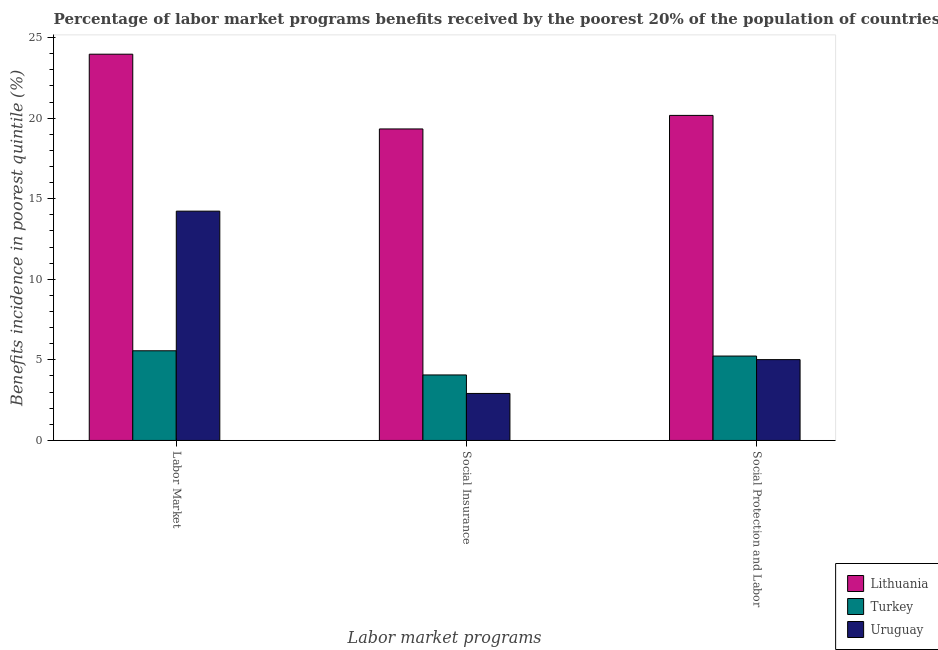How many groups of bars are there?
Offer a terse response. 3. Are the number of bars per tick equal to the number of legend labels?
Your answer should be compact. Yes. What is the label of the 3rd group of bars from the left?
Keep it short and to the point. Social Protection and Labor. What is the percentage of benefits received due to social insurance programs in Lithuania?
Provide a succinct answer. 19.33. Across all countries, what is the maximum percentage of benefits received due to social protection programs?
Keep it short and to the point. 20.17. Across all countries, what is the minimum percentage of benefits received due to social protection programs?
Offer a very short reply. 5.02. In which country was the percentage of benefits received due to social insurance programs maximum?
Your answer should be compact. Lithuania. What is the total percentage of benefits received due to social insurance programs in the graph?
Provide a succinct answer. 26.31. What is the difference between the percentage of benefits received due to labor market programs in Lithuania and that in Uruguay?
Your answer should be very brief. 9.74. What is the difference between the percentage of benefits received due to social insurance programs in Lithuania and the percentage of benefits received due to labor market programs in Uruguay?
Ensure brevity in your answer.  5.1. What is the average percentage of benefits received due to labor market programs per country?
Make the answer very short. 14.59. What is the difference between the percentage of benefits received due to labor market programs and percentage of benefits received due to social insurance programs in Lithuania?
Make the answer very short. 4.64. In how many countries, is the percentage of benefits received due to social insurance programs greater than 11 %?
Ensure brevity in your answer.  1. What is the ratio of the percentage of benefits received due to social protection programs in Lithuania to that in Turkey?
Offer a terse response. 3.85. What is the difference between the highest and the second highest percentage of benefits received due to social insurance programs?
Give a very brief answer. 15.26. What is the difference between the highest and the lowest percentage of benefits received due to social insurance programs?
Make the answer very short. 16.41. In how many countries, is the percentage of benefits received due to labor market programs greater than the average percentage of benefits received due to labor market programs taken over all countries?
Offer a terse response. 1. Is the sum of the percentage of benefits received due to labor market programs in Turkey and Lithuania greater than the maximum percentage of benefits received due to social protection programs across all countries?
Make the answer very short. Yes. What does the 1st bar from the left in Social Insurance represents?
Provide a succinct answer. Lithuania. What does the 2nd bar from the right in Social Protection and Labor represents?
Your answer should be compact. Turkey. Is it the case that in every country, the sum of the percentage of benefits received due to labor market programs and percentage of benefits received due to social insurance programs is greater than the percentage of benefits received due to social protection programs?
Make the answer very short. Yes. How many countries are there in the graph?
Offer a terse response. 3. Are the values on the major ticks of Y-axis written in scientific E-notation?
Offer a very short reply. No. Does the graph contain grids?
Ensure brevity in your answer.  No. Where does the legend appear in the graph?
Give a very brief answer. Bottom right. What is the title of the graph?
Your answer should be very brief. Percentage of labor market programs benefits received by the poorest 20% of the population of countries. Does "Latin America(all income levels)" appear as one of the legend labels in the graph?
Provide a short and direct response. No. What is the label or title of the X-axis?
Offer a terse response. Labor market programs. What is the label or title of the Y-axis?
Provide a succinct answer. Benefits incidence in poorest quintile (%). What is the Benefits incidence in poorest quintile (%) in Lithuania in Labor Market?
Provide a short and direct response. 23.97. What is the Benefits incidence in poorest quintile (%) of Turkey in Labor Market?
Keep it short and to the point. 5.56. What is the Benefits incidence in poorest quintile (%) in Uruguay in Labor Market?
Make the answer very short. 14.23. What is the Benefits incidence in poorest quintile (%) of Lithuania in Social Insurance?
Offer a very short reply. 19.33. What is the Benefits incidence in poorest quintile (%) of Turkey in Social Insurance?
Provide a succinct answer. 4.06. What is the Benefits incidence in poorest quintile (%) in Uruguay in Social Insurance?
Ensure brevity in your answer.  2.92. What is the Benefits incidence in poorest quintile (%) of Lithuania in Social Protection and Labor?
Offer a terse response. 20.17. What is the Benefits incidence in poorest quintile (%) of Turkey in Social Protection and Labor?
Your response must be concise. 5.24. What is the Benefits incidence in poorest quintile (%) of Uruguay in Social Protection and Labor?
Your answer should be very brief. 5.02. Across all Labor market programs, what is the maximum Benefits incidence in poorest quintile (%) of Lithuania?
Ensure brevity in your answer.  23.97. Across all Labor market programs, what is the maximum Benefits incidence in poorest quintile (%) in Turkey?
Your answer should be compact. 5.56. Across all Labor market programs, what is the maximum Benefits incidence in poorest quintile (%) of Uruguay?
Provide a succinct answer. 14.23. Across all Labor market programs, what is the minimum Benefits incidence in poorest quintile (%) in Lithuania?
Your response must be concise. 19.33. Across all Labor market programs, what is the minimum Benefits incidence in poorest quintile (%) in Turkey?
Your answer should be very brief. 4.06. Across all Labor market programs, what is the minimum Benefits incidence in poorest quintile (%) of Uruguay?
Your answer should be compact. 2.92. What is the total Benefits incidence in poorest quintile (%) in Lithuania in the graph?
Your answer should be very brief. 63.47. What is the total Benefits incidence in poorest quintile (%) in Turkey in the graph?
Offer a terse response. 14.87. What is the total Benefits incidence in poorest quintile (%) of Uruguay in the graph?
Provide a short and direct response. 22.16. What is the difference between the Benefits incidence in poorest quintile (%) in Lithuania in Labor Market and that in Social Insurance?
Give a very brief answer. 4.64. What is the difference between the Benefits incidence in poorest quintile (%) in Turkey in Labor Market and that in Social Insurance?
Offer a terse response. 1.5. What is the difference between the Benefits incidence in poorest quintile (%) of Uruguay in Labor Market and that in Social Insurance?
Your response must be concise. 11.31. What is the difference between the Benefits incidence in poorest quintile (%) in Lithuania in Labor Market and that in Social Protection and Labor?
Offer a terse response. 3.8. What is the difference between the Benefits incidence in poorest quintile (%) of Turkey in Labor Market and that in Social Protection and Labor?
Offer a very short reply. 0.33. What is the difference between the Benefits incidence in poorest quintile (%) of Uruguay in Labor Market and that in Social Protection and Labor?
Ensure brevity in your answer.  9.21. What is the difference between the Benefits incidence in poorest quintile (%) in Lithuania in Social Insurance and that in Social Protection and Labor?
Your response must be concise. -0.84. What is the difference between the Benefits incidence in poorest quintile (%) in Turkey in Social Insurance and that in Social Protection and Labor?
Provide a short and direct response. -1.17. What is the difference between the Benefits incidence in poorest quintile (%) in Uruguay in Social Insurance and that in Social Protection and Labor?
Keep it short and to the point. -2.1. What is the difference between the Benefits incidence in poorest quintile (%) in Lithuania in Labor Market and the Benefits incidence in poorest quintile (%) in Turkey in Social Insurance?
Your answer should be very brief. 19.9. What is the difference between the Benefits incidence in poorest quintile (%) of Lithuania in Labor Market and the Benefits incidence in poorest quintile (%) of Uruguay in Social Insurance?
Ensure brevity in your answer.  21.05. What is the difference between the Benefits incidence in poorest quintile (%) in Turkey in Labor Market and the Benefits incidence in poorest quintile (%) in Uruguay in Social Insurance?
Ensure brevity in your answer.  2.65. What is the difference between the Benefits incidence in poorest quintile (%) of Lithuania in Labor Market and the Benefits incidence in poorest quintile (%) of Turkey in Social Protection and Labor?
Ensure brevity in your answer.  18.73. What is the difference between the Benefits incidence in poorest quintile (%) in Lithuania in Labor Market and the Benefits incidence in poorest quintile (%) in Uruguay in Social Protection and Labor?
Your answer should be compact. 18.95. What is the difference between the Benefits incidence in poorest quintile (%) in Turkey in Labor Market and the Benefits incidence in poorest quintile (%) in Uruguay in Social Protection and Labor?
Provide a succinct answer. 0.55. What is the difference between the Benefits incidence in poorest quintile (%) in Lithuania in Social Insurance and the Benefits incidence in poorest quintile (%) in Turkey in Social Protection and Labor?
Provide a succinct answer. 14.09. What is the difference between the Benefits incidence in poorest quintile (%) of Lithuania in Social Insurance and the Benefits incidence in poorest quintile (%) of Uruguay in Social Protection and Labor?
Your answer should be compact. 14.31. What is the difference between the Benefits incidence in poorest quintile (%) in Turkey in Social Insurance and the Benefits incidence in poorest quintile (%) in Uruguay in Social Protection and Labor?
Give a very brief answer. -0.95. What is the average Benefits incidence in poorest quintile (%) of Lithuania per Labor market programs?
Give a very brief answer. 21.16. What is the average Benefits incidence in poorest quintile (%) in Turkey per Labor market programs?
Provide a short and direct response. 4.96. What is the average Benefits incidence in poorest quintile (%) in Uruguay per Labor market programs?
Ensure brevity in your answer.  7.39. What is the difference between the Benefits incidence in poorest quintile (%) of Lithuania and Benefits incidence in poorest quintile (%) of Turkey in Labor Market?
Your answer should be very brief. 18.4. What is the difference between the Benefits incidence in poorest quintile (%) of Lithuania and Benefits incidence in poorest quintile (%) of Uruguay in Labor Market?
Give a very brief answer. 9.74. What is the difference between the Benefits incidence in poorest quintile (%) in Turkey and Benefits incidence in poorest quintile (%) in Uruguay in Labor Market?
Provide a succinct answer. -8.66. What is the difference between the Benefits incidence in poorest quintile (%) in Lithuania and Benefits incidence in poorest quintile (%) in Turkey in Social Insurance?
Give a very brief answer. 15.26. What is the difference between the Benefits incidence in poorest quintile (%) in Lithuania and Benefits incidence in poorest quintile (%) in Uruguay in Social Insurance?
Your response must be concise. 16.41. What is the difference between the Benefits incidence in poorest quintile (%) of Turkey and Benefits incidence in poorest quintile (%) of Uruguay in Social Insurance?
Keep it short and to the point. 1.15. What is the difference between the Benefits incidence in poorest quintile (%) in Lithuania and Benefits incidence in poorest quintile (%) in Turkey in Social Protection and Labor?
Provide a succinct answer. 14.93. What is the difference between the Benefits incidence in poorest quintile (%) of Lithuania and Benefits incidence in poorest quintile (%) of Uruguay in Social Protection and Labor?
Give a very brief answer. 15.15. What is the difference between the Benefits incidence in poorest quintile (%) of Turkey and Benefits incidence in poorest quintile (%) of Uruguay in Social Protection and Labor?
Give a very brief answer. 0.22. What is the ratio of the Benefits incidence in poorest quintile (%) in Lithuania in Labor Market to that in Social Insurance?
Give a very brief answer. 1.24. What is the ratio of the Benefits incidence in poorest quintile (%) of Turkey in Labor Market to that in Social Insurance?
Provide a short and direct response. 1.37. What is the ratio of the Benefits incidence in poorest quintile (%) of Uruguay in Labor Market to that in Social Insurance?
Make the answer very short. 4.88. What is the ratio of the Benefits incidence in poorest quintile (%) in Lithuania in Labor Market to that in Social Protection and Labor?
Make the answer very short. 1.19. What is the ratio of the Benefits incidence in poorest quintile (%) of Turkey in Labor Market to that in Social Protection and Labor?
Keep it short and to the point. 1.06. What is the ratio of the Benefits incidence in poorest quintile (%) of Uruguay in Labor Market to that in Social Protection and Labor?
Offer a very short reply. 2.84. What is the ratio of the Benefits incidence in poorest quintile (%) in Turkey in Social Insurance to that in Social Protection and Labor?
Your answer should be compact. 0.78. What is the ratio of the Benefits incidence in poorest quintile (%) in Uruguay in Social Insurance to that in Social Protection and Labor?
Offer a very short reply. 0.58. What is the difference between the highest and the second highest Benefits incidence in poorest quintile (%) in Lithuania?
Your answer should be very brief. 3.8. What is the difference between the highest and the second highest Benefits incidence in poorest quintile (%) in Turkey?
Offer a very short reply. 0.33. What is the difference between the highest and the second highest Benefits incidence in poorest quintile (%) of Uruguay?
Your answer should be very brief. 9.21. What is the difference between the highest and the lowest Benefits incidence in poorest quintile (%) in Lithuania?
Your response must be concise. 4.64. What is the difference between the highest and the lowest Benefits incidence in poorest quintile (%) in Turkey?
Your response must be concise. 1.5. What is the difference between the highest and the lowest Benefits incidence in poorest quintile (%) of Uruguay?
Offer a very short reply. 11.31. 